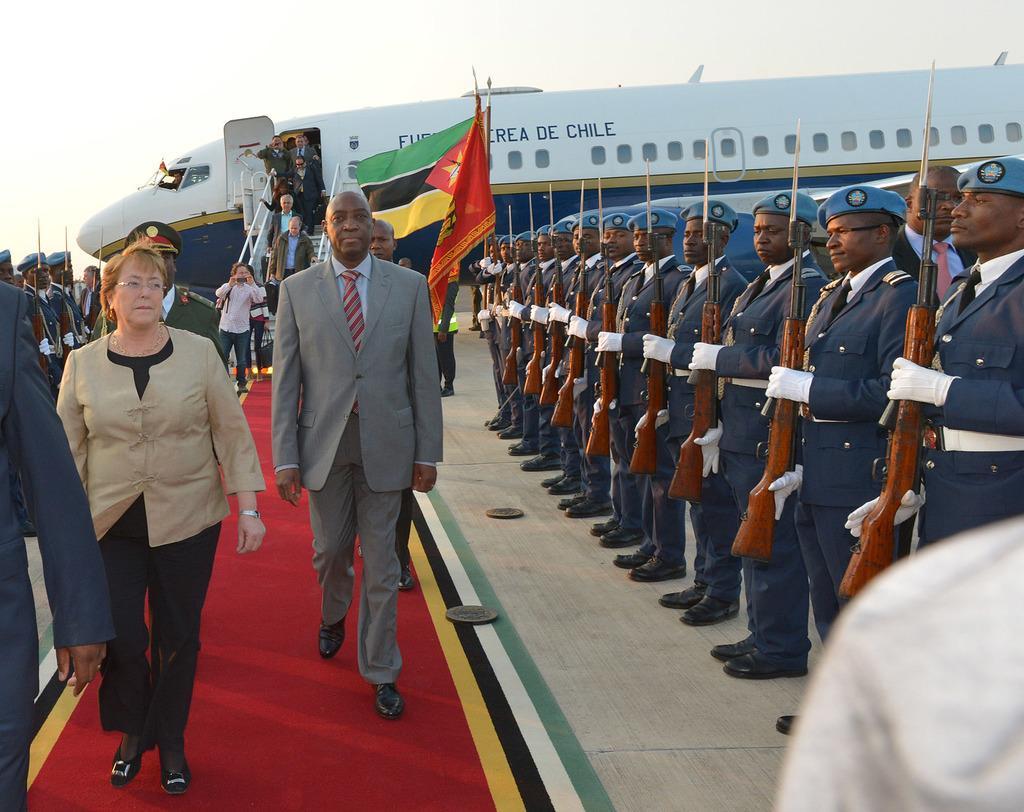In one or two sentences, can you explain what this image depicts? On the left side there is a red carpet. On that few people are walking. On the right side there are many people wearing caps and gloves are holding guns. In the back there are flags. Also there is a flight with windows, steps and railings. There are few people walking on the steps. On the left side there are few people wearing caps and gloves are holding guns. In the background there is sky. 